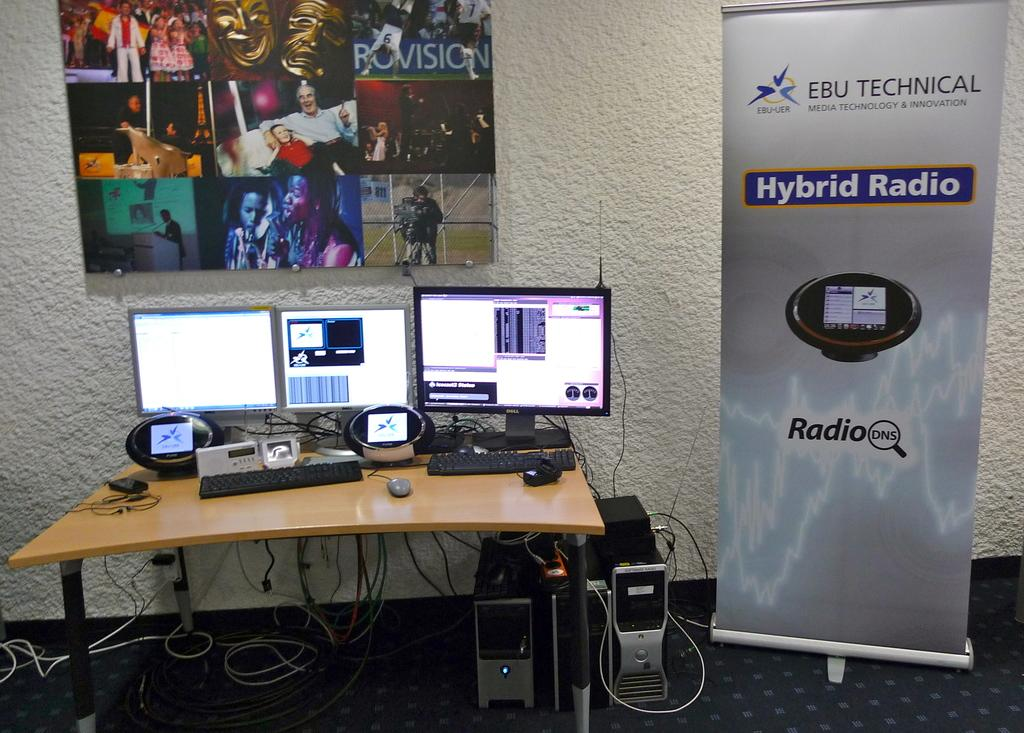<image>
Give a short and clear explanation of the subsequent image. A Dell monitor sits to the right of 2 other monitors and to the left of a tall display advertising Hybrid Radio. 